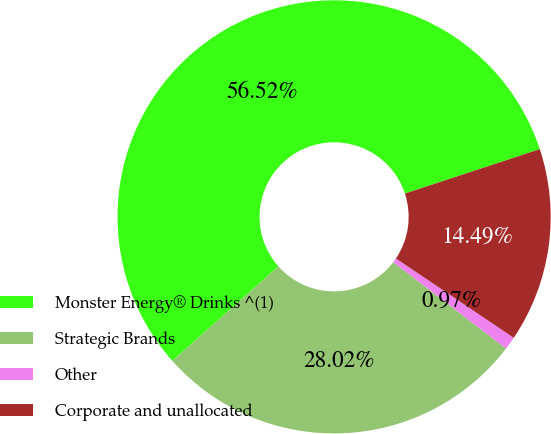Convert chart to OTSL. <chart><loc_0><loc_0><loc_500><loc_500><pie_chart><fcel>Monster Energy® Drinks ^(1)<fcel>Strategic Brands<fcel>Other<fcel>Corporate and unallocated<nl><fcel>56.53%<fcel>28.02%<fcel>0.97%<fcel>14.49%<nl></chart> 